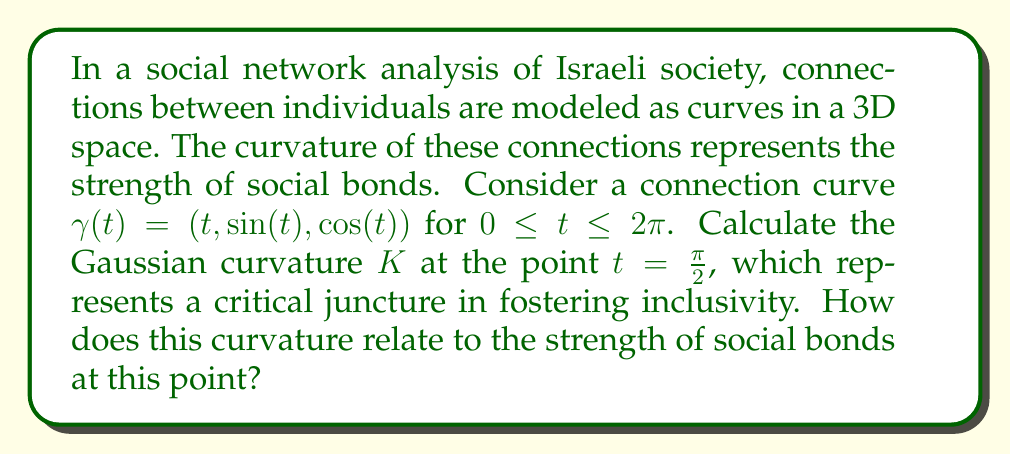Show me your answer to this math problem. To solve this problem, we'll follow these steps:

1) First, we need to calculate the first and second fundamental forms of the surface.

2) The curve $\gamma(t) = (t, \sin(t), \cos(t))$ can be parameterized as a surface:
   $S(u,v) = (u, \sin(v), \cos(v))$

3) Calculate the partial derivatives:
   $S_u = (1, 0, 0)$
   $S_v = (0, \cos(v), -\sin(v))$

4) The first fundamental form coefficients:
   $E = S_u \cdot S_u = 1$
   $F = S_u \cdot S_v = 0$
   $G = S_v \cdot S_v = \cos^2(v) + \sin^2(v) = 1$

5) Calculate the second partial derivatives:
   $S_{uu} = (0, 0, 0)$
   $S_{uv} = (0, 0, 0)$
   $S_{vv} = (0, -\sin(v), -\cos(v))$

6) Calculate the normal vector:
   $N = \frac{S_u \times S_v}{|S_u \times S_v|} = (0, -\sin(v), \cos(v))$

7) The second fundamental form coefficients:
   $L = S_{uu} \cdot N = 0$
   $M = S_{uv} \cdot N = 0$
   $N = S_{vv} \cdot N = -\sin^2(v) - \cos^2(v) = -1$

8) The Gaussian curvature is given by:
   $$K = \frac{LN - M^2}{EG - F^2}$$

9) Substituting the values:
   $$K = \frac{(0)(-1) - 0^2}{(1)(1) - 0^2} = 0$$

10) This result is independent of $v$, so it holds for $t = \frac{\pi}{2}$.

The Gaussian curvature being zero indicates that the surface is locally flat at this point. In the context of social networks, this suggests that the strength of social bonds at this critical juncture for fostering inclusivity is neither particularly strong nor weak, but rather neutral or transitional. This could represent an opportunity for intervention to strengthen these connections and promote greater inclusivity in Israeli society.
Answer: The Gaussian curvature $K$ at $t = \frac{\pi}{2}$ is 0. This indicates a locally flat surface, suggesting neutral or transitional strength in social bonds at this critical point for fostering inclusivity. 